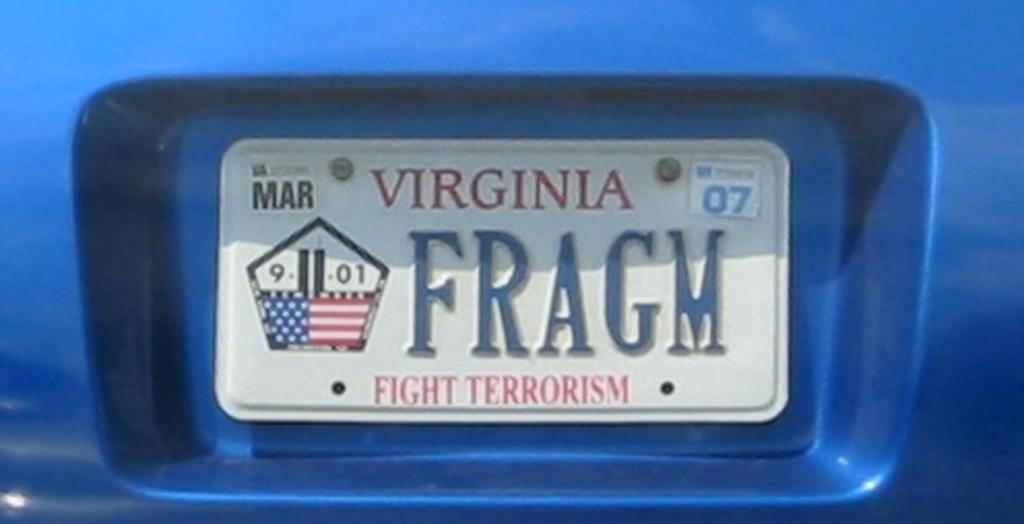<image>
Describe the image concisely. White Virginia license plate which says FRAGM on it. 